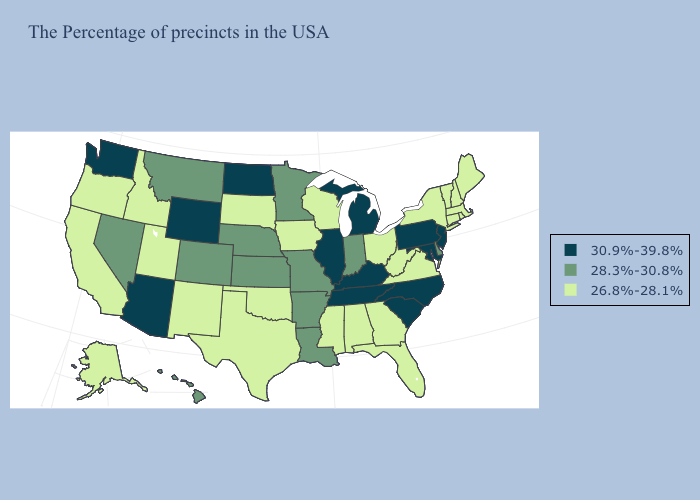Does Pennsylvania have the highest value in the Northeast?
Quick response, please. Yes. Does the first symbol in the legend represent the smallest category?
Quick response, please. No. Does Missouri have the highest value in the USA?
Be succinct. No. Name the states that have a value in the range 30.9%-39.8%?
Give a very brief answer. New Jersey, Maryland, Pennsylvania, North Carolina, South Carolina, Michigan, Kentucky, Tennessee, Illinois, North Dakota, Wyoming, Arizona, Washington. What is the value of Texas?
Quick response, please. 26.8%-28.1%. Does Idaho have a lower value than South Dakota?
Short answer required. No. Name the states that have a value in the range 28.3%-30.8%?
Give a very brief answer. Delaware, Indiana, Louisiana, Missouri, Arkansas, Minnesota, Kansas, Nebraska, Colorado, Montana, Nevada, Hawaii. Does Oregon have a lower value than Ohio?
Quick response, please. No. Which states have the lowest value in the USA?
Write a very short answer. Maine, Massachusetts, Rhode Island, New Hampshire, Vermont, Connecticut, New York, Virginia, West Virginia, Ohio, Florida, Georgia, Alabama, Wisconsin, Mississippi, Iowa, Oklahoma, Texas, South Dakota, New Mexico, Utah, Idaho, California, Oregon, Alaska. Name the states that have a value in the range 30.9%-39.8%?
Quick response, please. New Jersey, Maryland, Pennsylvania, North Carolina, South Carolina, Michigan, Kentucky, Tennessee, Illinois, North Dakota, Wyoming, Arizona, Washington. What is the lowest value in the West?
Write a very short answer. 26.8%-28.1%. What is the value of Arizona?
Concise answer only. 30.9%-39.8%. Does the first symbol in the legend represent the smallest category?
Concise answer only. No. Name the states that have a value in the range 30.9%-39.8%?
Concise answer only. New Jersey, Maryland, Pennsylvania, North Carolina, South Carolina, Michigan, Kentucky, Tennessee, Illinois, North Dakota, Wyoming, Arizona, Washington. 